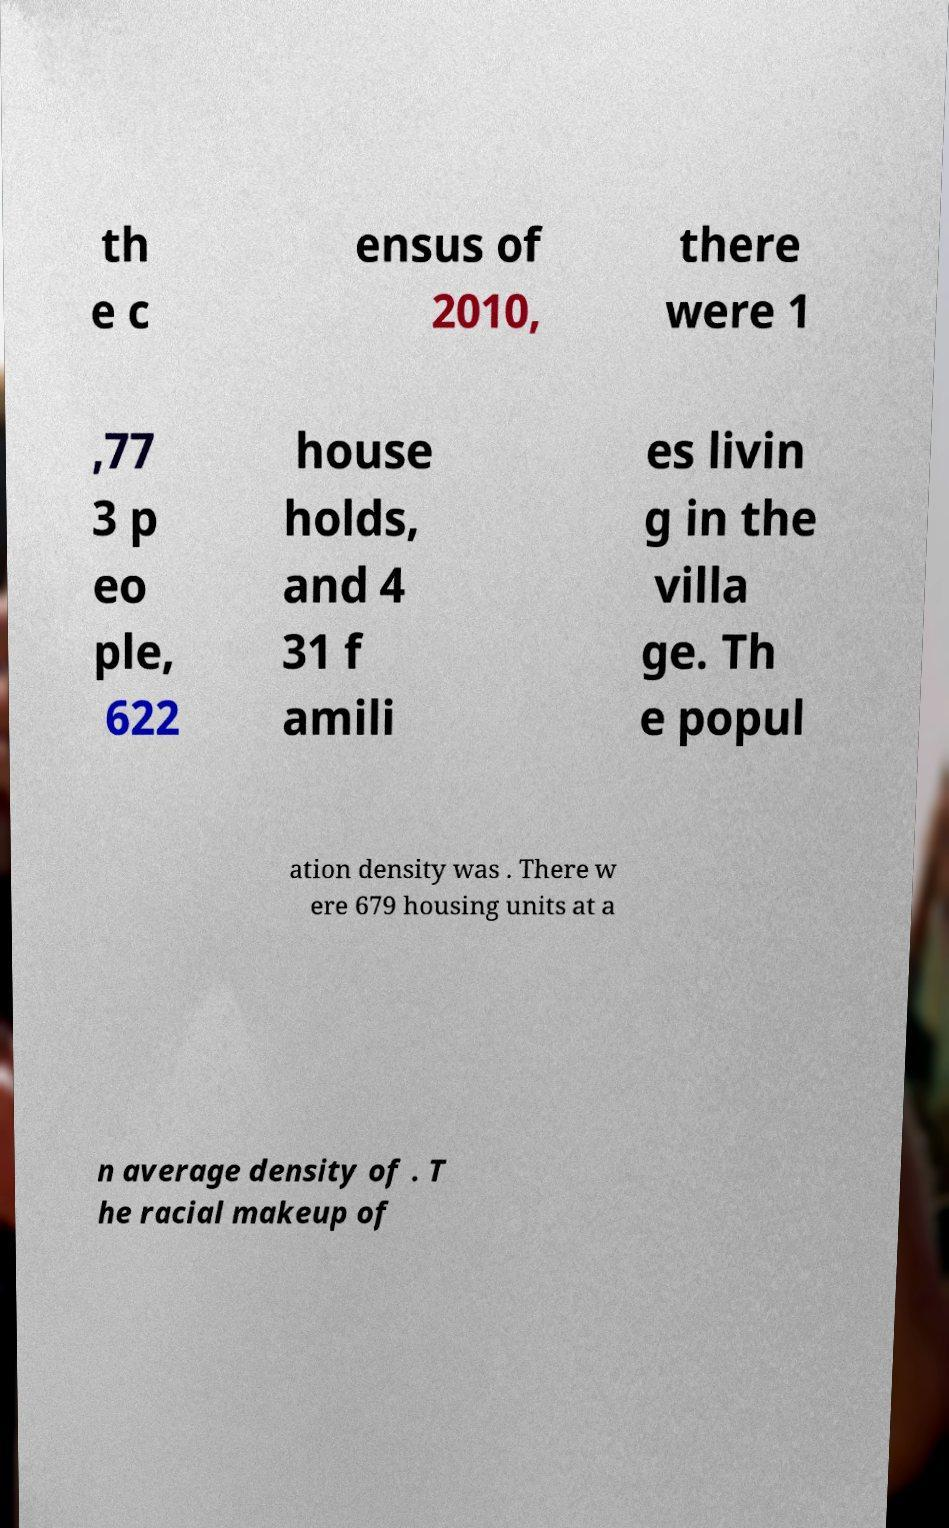What messages or text are displayed in this image? I need them in a readable, typed format. th e c ensus of 2010, there were 1 ,77 3 p eo ple, 622 house holds, and 4 31 f amili es livin g in the villa ge. Th e popul ation density was . There w ere 679 housing units at a n average density of . T he racial makeup of 